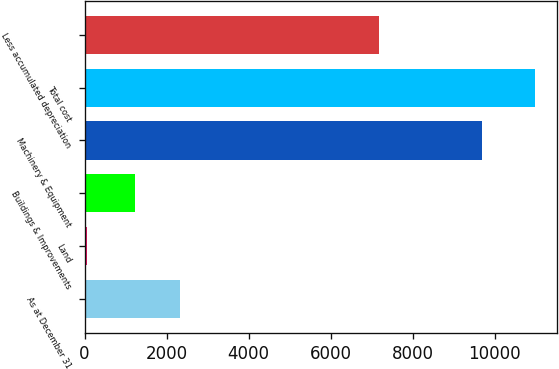Convert chart. <chart><loc_0><loc_0><loc_500><loc_500><bar_chart><fcel>As at December 31<fcel>Land<fcel>Buildings & Improvements<fcel>Machinery & Equipment<fcel>Total cost<fcel>Less accumulated depreciation<nl><fcel>2331.1<fcel>56<fcel>1239<fcel>9682<fcel>10977<fcel>7177<nl></chart> 